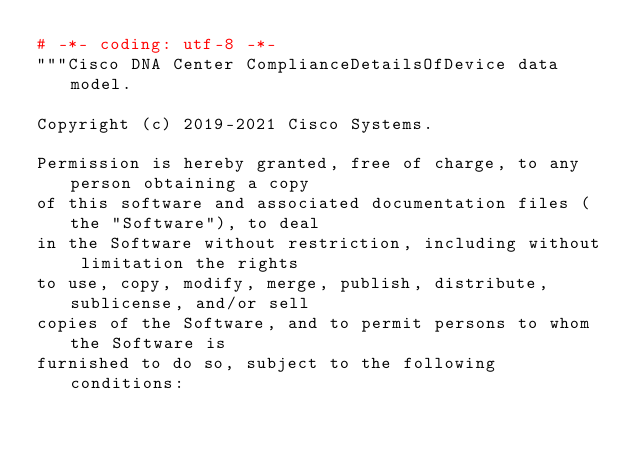<code> <loc_0><loc_0><loc_500><loc_500><_Python_># -*- coding: utf-8 -*-
"""Cisco DNA Center ComplianceDetailsOfDevice data model.

Copyright (c) 2019-2021 Cisco Systems.

Permission is hereby granted, free of charge, to any person obtaining a copy
of this software and associated documentation files (the "Software"), to deal
in the Software without restriction, including without limitation the rights
to use, copy, modify, merge, publish, distribute, sublicense, and/or sell
copies of the Software, and to permit persons to whom the Software is
furnished to do so, subject to the following conditions:
</code> 